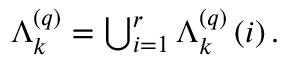<formula> <loc_0><loc_0><loc_500><loc_500>\begin{array} { r } { \Lambda _ { k } ^ { \left ( q \right ) } = \bigcup _ { i = 1 } ^ { r } \Lambda _ { k } ^ { \left ( q \right ) } \left ( i \right ) . } \end{array}</formula> 